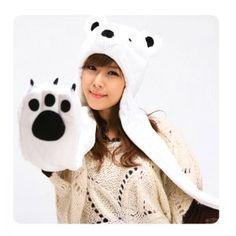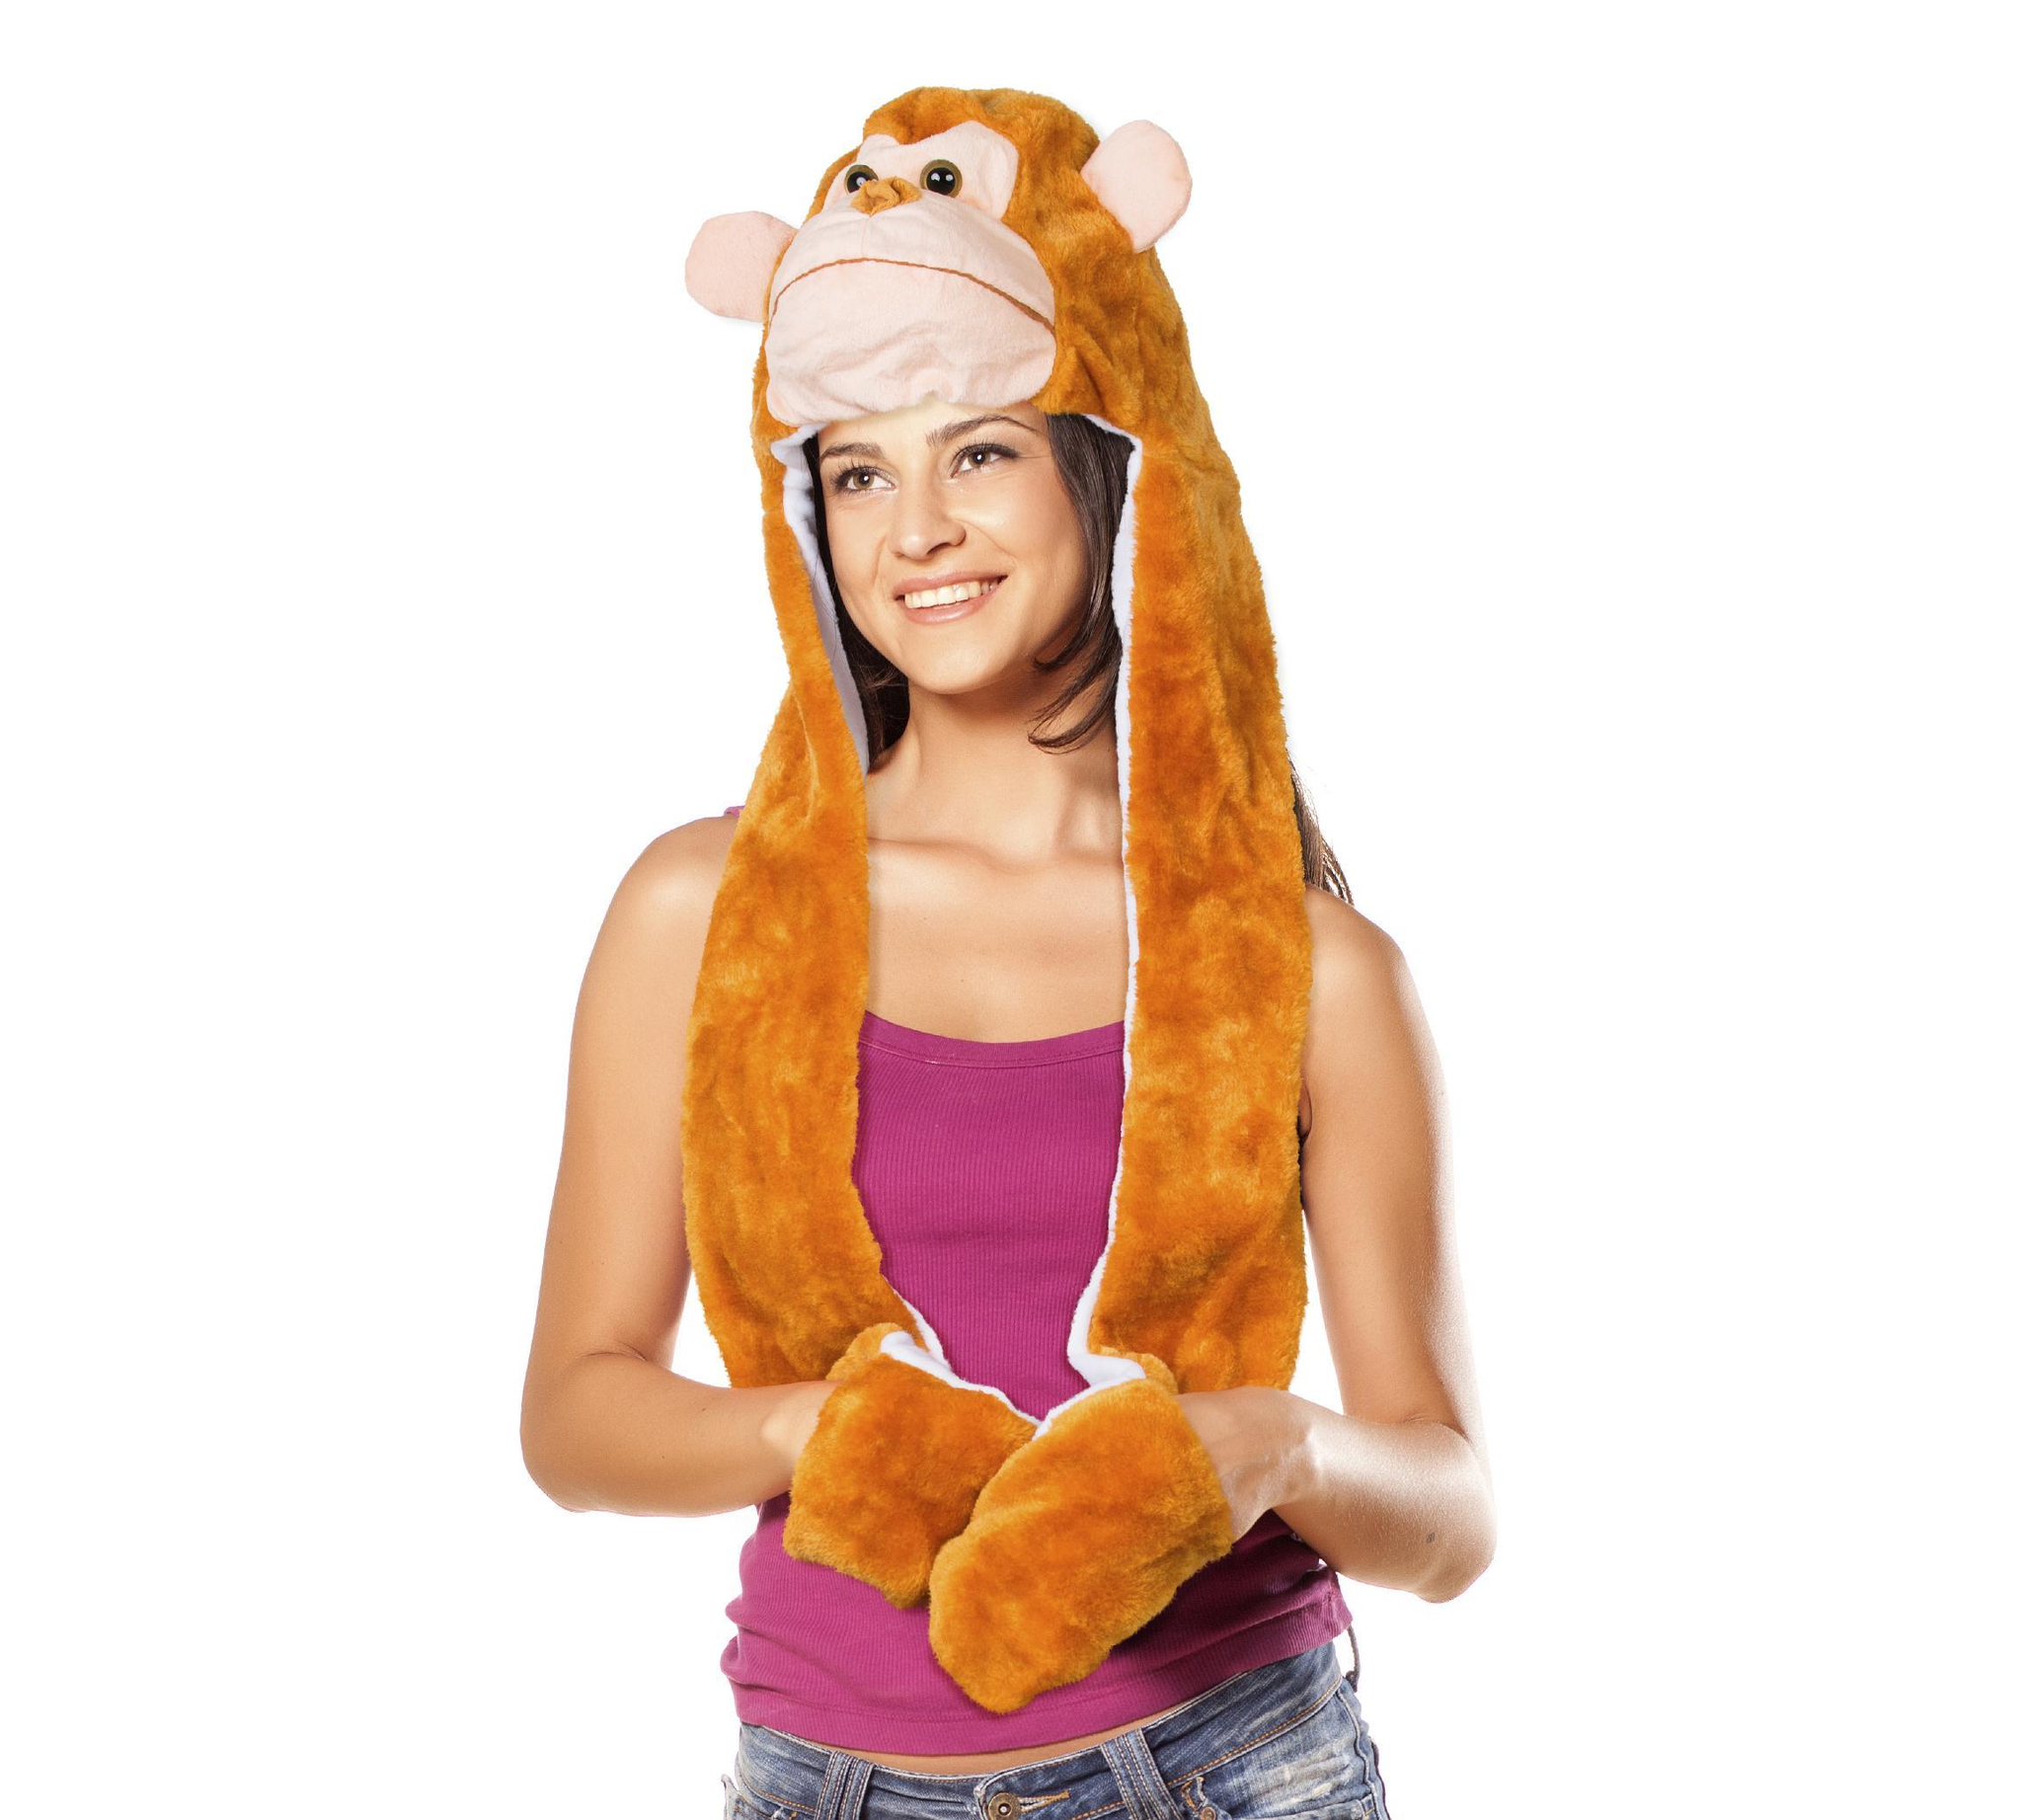The first image is the image on the left, the second image is the image on the right. Considering the images on both sides, is "A young Asian woman in a pale knit top is holding at least one paw-decorated mitten up to the camera." valid? Answer yes or no. Yes. The first image is the image on the left, the second image is the image on the right. Given the left and right images, does the statement "The person in the image on the left is wearing a hat that looks like a bear." hold true? Answer yes or no. Yes. 